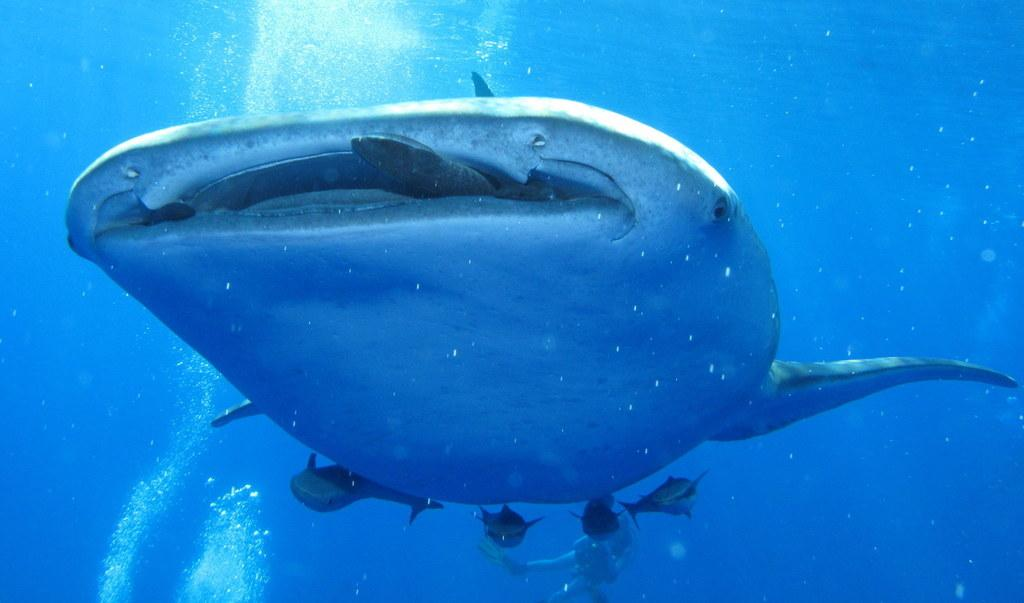What is the main subject of the image? The main subject of the image is a whale. What other creatures can be seen in the image? There are fishes in the image. Where are the whale and fishes located? Both the whale and fishes are in the water. What country does the robin in the image represent? There is no robin present in the image, and therefore no country representation can be observed. 